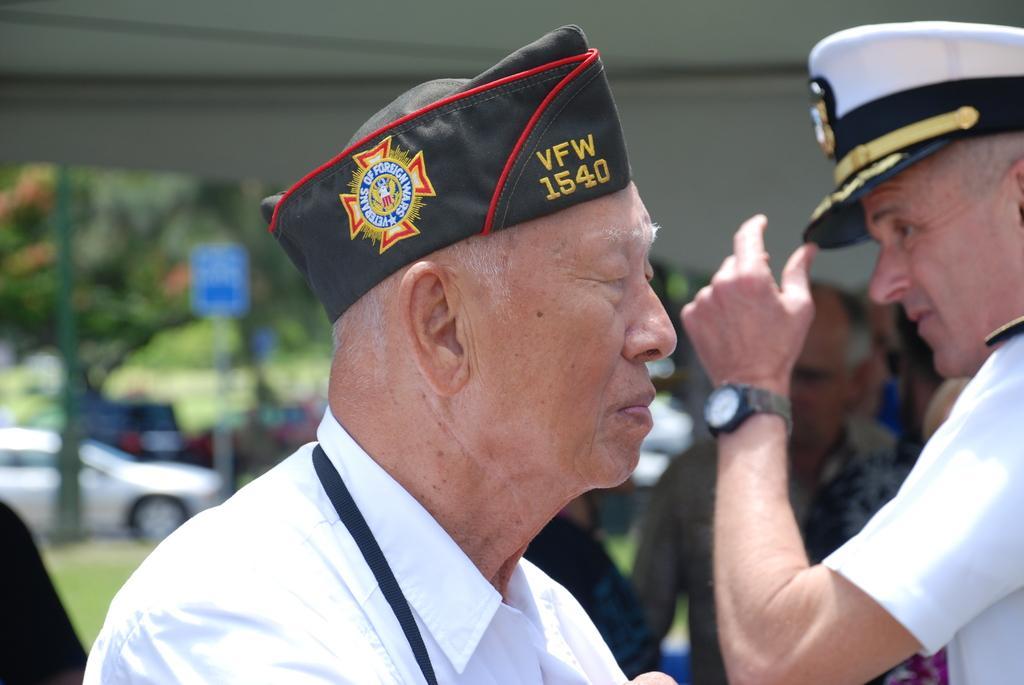Can you describe this image briefly? Here I can see two men wearing uniforms and caps on their heads. At the back of these men I can see some more people. In the background there are few poles, trees and a car. At the top of the image there is a cloth which seems to be a tent. 